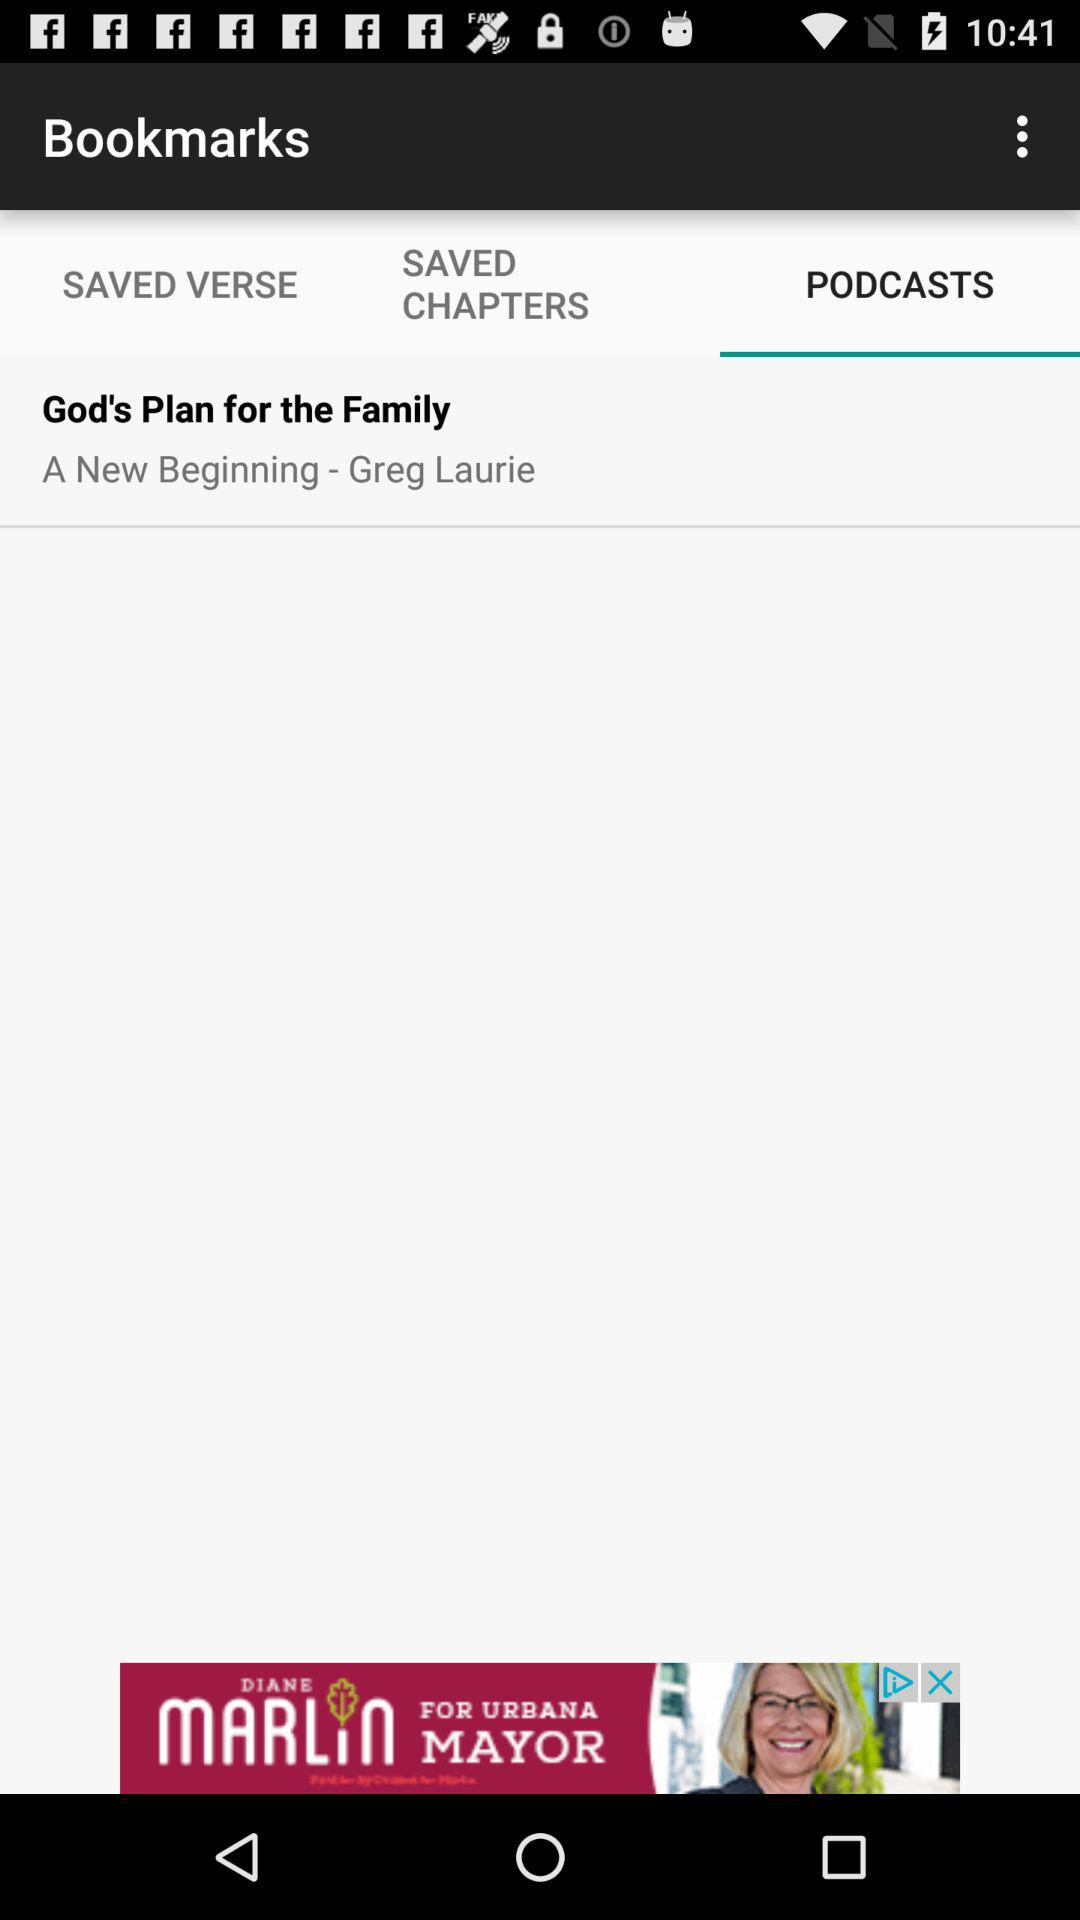What is the title of the podcast? The title of the podcast is "God's Plan for the Family". 